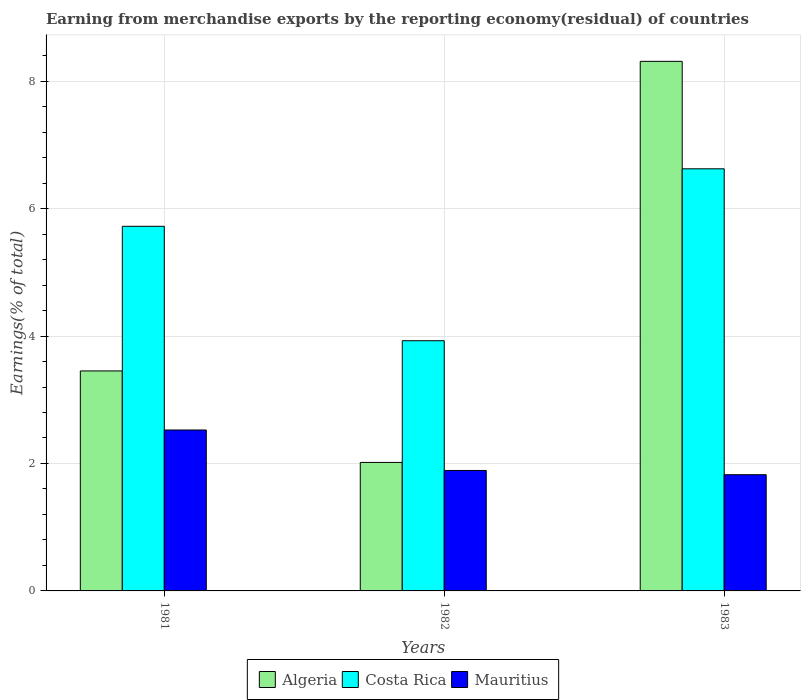How many different coloured bars are there?
Your answer should be compact. 3. How many groups of bars are there?
Ensure brevity in your answer.  3. Are the number of bars per tick equal to the number of legend labels?
Provide a short and direct response. Yes. Are the number of bars on each tick of the X-axis equal?
Provide a short and direct response. Yes. How many bars are there on the 2nd tick from the left?
Keep it short and to the point. 3. In how many cases, is the number of bars for a given year not equal to the number of legend labels?
Give a very brief answer. 0. What is the percentage of amount earned from merchandise exports in Mauritius in 1981?
Ensure brevity in your answer.  2.53. Across all years, what is the maximum percentage of amount earned from merchandise exports in Algeria?
Ensure brevity in your answer.  8.31. Across all years, what is the minimum percentage of amount earned from merchandise exports in Algeria?
Your response must be concise. 2.02. In which year was the percentage of amount earned from merchandise exports in Mauritius minimum?
Provide a succinct answer. 1983. What is the total percentage of amount earned from merchandise exports in Algeria in the graph?
Offer a terse response. 13.78. What is the difference between the percentage of amount earned from merchandise exports in Mauritius in 1981 and that in 1983?
Offer a terse response. 0.7. What is the difference between the percentage of amount earned from merchandise exports in Mauritius in 1981 and the percentage of amount earned from merchandise exports in Costa Rica in 1982?
Provide a short and direct response. -1.4. What is the average percentage of amount earned from merchandise exports in Algeria per year?
Your response must be concise. 4.59. In the year 1982, what is the difference between the percentage of amount earned from merchandise exports in Mauritius and percentage of amount earned from merchandise exports in Algeria?
Your response must be concise. -0.13. In how many years, is the percentage of amount earned from merchandise exports in Algeria greater than 3.6 %?
Provide a succinct answer. 1. What is the ratio of the percentage of amount earned from merchandise exports in Costa Rica in 1982 to that in 1983?
Your answer should be very brief. 0.59. Is the percentage of amount earned from merchandise exports in Mauritius in 1982 less than that in 1983?
Give a very brief answer. No. Is the difference between the percentage of amount earned from merchandise exports in Mauritius in 1981 and 1983 greater than the difference between the percentage of amount earned from merchandise exports in Algeria in 1981 and 1983?
Provide a succinct answer. Yes. What is the difference between the highest and the second highest percentage of amount earned from merchandise exports in Algeria?
Your answer should be very brief. 4.86. What is the difference between the highest and the lowest percentage of amount earned from merchandise exports in Algeria?
Offer a terse response. 6.29. In how many years, is the percentage of amount earned from merchandise exports in Costa Rica greater than the average percentage of amount earned from merchandise exports in Costa Rica taken over all years?
Provide a short and direct response. 2. What does the 1st bar from the left in 1983 represents?
Give a very brief answer. Algeria. How many bars are there?
Your answer should be compact. 9. Are all the bars in the graph horizontal?
Offer a terse response. No. Are the values on the major ticks of Y-axis written in scientific E-notation?
Keep it short and to the point. No. How are the legend labels stacked?
Offer a very short reply. Horizontal. What is the title of the graph?
Ensure brevity in your answer.  Earning from merchandise exports by the reporting economy(residual) of countries. What is the label or title of the Y-axis?
Your answer should be very brief. Earnings(% of total). What is the Earnings(% of total) in Algeria in 1981?
Provide a succinct answer. 3.45. What is the Earnings(% of total) in Costa Rica in 1981?
Offer a very short reply. 5.72. What is the Earnings(% of total) of Mauritius in 1981?
Provide a short and direct response. 2.53. What is the Earnings(% of total) of Algeria in 1982?
Keep it short and to the point. 2.02. What is the Earnings(% of total) in Costa Rica in 1982?
Offer a terse response. 3.93. What is the Earnings(% of total) of Mauritius in 1982?
Make the answer very short. 1.89. What is the Earnings(% of total) of Algeria in 1983?
Provide a succinct answer. 8.31. What is the Earnings(% of total) of Costa Rica in 1983?
Keep it short and to the point. 6.62. What is the Earnings(% of total) of Mauritius in 1983?
Your answer should be very brief. 1.82. Across all years, what is the maximum Earnings(% of total) of Algeria?
Provide a short and direct response. 8.31. Across all years, what is the maximum Earnings(% of total) in Costa Rica?
Make the answer very short. 6.62. Across all years, what is the maximum Earnings(% of total) of Mauritius?
Offer a terse response. 2.53. Across all years, what is the minimum Earnings(% of total) of Algeria?
Make the answer very short. 2.02. Across all years, what is the minimum Earnings(% of total) in Costa Rica?
Your answer should be compact. 3.93. Across all years, what is the minimum Earnings(% of total) in Mauritius?
Provide a succinct answer. 1.82. What is the total Earnings(% of total) in Algeria in the graph?
Make the answer very short. 13.78. What is the total Earnings(% of total) of Costa Rica in the graph?
Your response must be concise. 16.27. What is the total Earnings(% of total) of Mauritius in the graph?
Offer a terse response. 6.24. What is the difference between the Earnings(% of total) in Algeria in 1981 and that in 1982?
Offer a terse response. 1.44. What is the difference between the Earnings(% of total) in Costa Rica in 1981 and that in 1982?
Keep it short and to the point. 1.8. What is the difference between the Earnings(% of total) of Mauritius in 1981 and that in 1982?
Give a very brief answer. 0.64. What is the difference between the Earnings(% of total) in Algeria in 1981 and that in 1983?
Your response must be concise. -4.86. What is the difference between the Earnings(% of total) in Costa Rica in 1981 and that in 1983?
Provide a succinct answer. -0.9. What is the difference between the Earnings(% of total) in Mauritius in 1981 and that in 1983?
Offer a terse response. 0.7. What is the difference between the Earnings(% of total) in Algeria in 1982 and that in 1983?
Make the answer very short. -6.29. What is the difference between the Earnings(% of total) in Costa Rica in 1982 and that in 1983?
Keep it short and to the point. -2.7. What is the difference between the Earnings(% of total) of Mauritius in 1982 and that in 1983?
Keep it short and to the point. 0.07. What is the difference between the Earnings(% of total) of Algeria in 1981 and the Earnings(% of total) of Costa Rica in 1982?
Provide a succinct answer. -0.47. What is the difference between the Earnings(% of total) in Algeria in 1981 and the Earnings(% of total) in Mauritius in 1982?
Make the answer very short. 1.56. What is the difference between the Earnings(% of total) in Costa Rica in 1981 and the Earnings(% of total) in Mauritius in 1982?
Give a very brief answer. 3.83. What is the difference between the Earnings(% of total) of Algeria in 1981 and the Earnings(% of total) of Costa Rica in 1983?
Offer a very short reply. -3.17. What is the difference between the Earnings(% of total) of Algeria in 1981 and the Earnings(% of total) of Mauritius in 1983?
Give a very brief answer. 1.63. What is the difference between the Earnings(% of total) of Costa Rica in 1981 and the Earnings(% of total) of Mauritius in 1983?
Provide a succinct answer. 3.9. What is the difference between the Earnings(% of total) of Algeria in 1982 and the Earnings(% of total) of Costa Rica in 1983?
Ensure brevity in your answer.  -4.61. What is the difference between the Earnings(% of total) of Algeria in 1982 and the Earnings(% of total) of Mauritius in 1983?
Offer a very short reply. 0.19. What is the difference between the Earnings(% of total) of Costa Rica in 1982 and the Earnings(% of total) of Mauritius in 1983?
Provide a succinct answer. 2.1. What is the average Earnings(% of total) in Algeria per year?
Your answer should be compact. 4.59. What is the average Earnings(% of total) in Costa Rica per year?
Your answer should be very brief. 5.42. What is the average Earnings(% of total) in Mauritius per year?
Keep it short and to the point. 2.08. In the year 1981, what is the difference between the Earnings(% of total) in Algeria and Earnings(% of total) in Costa Rica?
Make the answer very short. -2.27. In the year 1981, what is the difference between the Earnings(% of total) in Algeria and Earnings(% of total) in Mauritius?
Offer a very short reply. 0.93. In the year 1981, what is the difference between the Earnings(% of total) in Costa Rica and Earnings(% of total) in Mauritius?
Provide a succinct answer. 3.2. In the year 1982, what is the difference between the Earnings(% of total) of Algeria and Earnings(% of total) of Costa Rica?
Your answer should be very brief. -1.91. In the year 1982, what is the difference between the Earnings(% of total) in Algeria and Earnings(% of total) in Mauritius?
Provide a short and direct response. 0.13. In the year 1982, what is the difference between the Earnings(% of total) in Costa Rica and Earnings(% of total) in Mauritius?
Ensure brevity in your answer.  2.04. In the year 1983, what is the difference between the Earnings(% of total) in Algeria and Earnings(% of total) in Costa Rica?
Make the answer very short. 1.69. In the year 1983, what is the difference between the Earnings(% of total) in Algeria and Earnings(% of total) in Mauritius?
Make the answer very short. 6.49. In the year 1983, what is the difference between the Earnings(% of total) in Costa Rica and Earnings(% of total) in Mauritius?
Ensure brevity in your answer.  4.8. What is the ratio of the Earnings(% of total) of Algeria in 1981 to that in 1982?
Provide a succinct answer. 1.71. What is the ratio of the Earnings(% of total) in Costa Rica in 1981 to that in 1982?
Your answer should be very brief. 1.46. What is the ratio of the Earnings(% of total) of Mauritius in 1981 to that in 1982?
Give a very brief answer. 1.34. What is the ratio of the Earnings(% of total) of Algeria in 1981 to that in 1983?
Offer a very short reply. 0.42. What is the ratio of the Earnings(% of total) in Costa Rica in 1981 to that in 1983?
Offer a terse response. 0.86. What is the ratio of the Earnings(% of total) of Mauritius in 1981 to that in 1983?
Provide a succinct answer. 1.38. What is the ratio of the Earnings(% of total) in Algeria in 1982 to that in 1983?
Provide a succinct answer. 0.24. What is the ratio of the Earnings(% of total) of Costa Rica in 1982 to that in 1983?
Make the answer very short. 0.59. What is the ratio of the Earnings(% of total) in Mauritius in 1982 to that in 1983?
Provide a succinct answer. 1.04. What is the difference between the highest and the second highest Earnings(% of total) of Algeria?
Your answer should be compact. 4.86. What is the difference between the highest and the second highest Earnings(% of total) of Costa Rica?
Your answer should be very brief. 0.9. What is the difference between the highest and the second highest Earnings(% of total) of Mauritius?
Offer a very short reply. 0.64. What is the difference between the highest and the lowest Earnings(% of total) in Algeria?
Your response must be concise. 6.29. What is the difference between the highest and the lowest Earnings(% of total) of Costa Rica?
Ensure brevity in your answer.  2.7. What is the difference between the highest and the lowest Earnings(% of total) of Mauritius?
Your response must be concise. 0.7. 